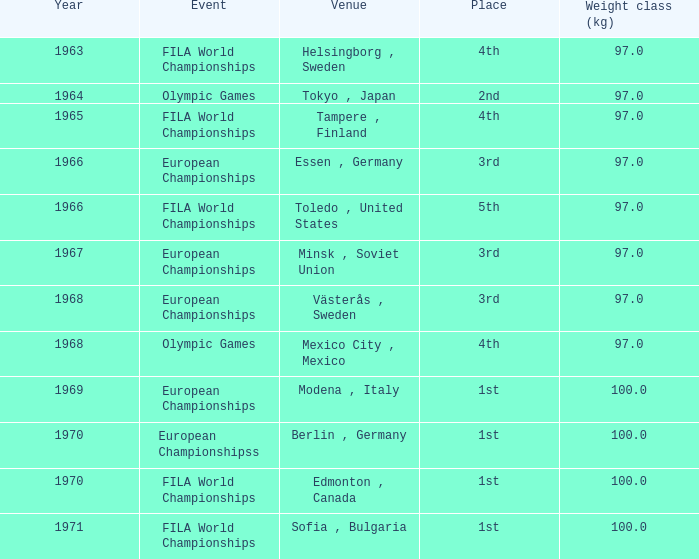What is the lowest year that has edmonton, canada as the venue with a weight class (kg) greater than 100? None. 